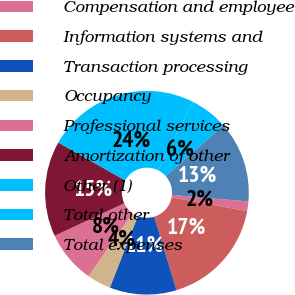Convert chart to OTSL. <chart><loc_0><loc_0><loc_500><loc_500><pie_chart><fcel>Compensation and employee<fcel>Information systems and<fcel>Transaction processing<fcel>Occupancy<fcel>Professional services<fcel>Amortization of other<fcel>Other (1)<fcel>Total other<fcel>Total expenses<nl><fcel>1.52%<fcel>17.42%<fcel>10.61%<fcel>3.79%<fcel>8.33%<fcel>15.15%<fcel>24.24%<fcel>6.06%<fcel>12.88%<nl></chart> 